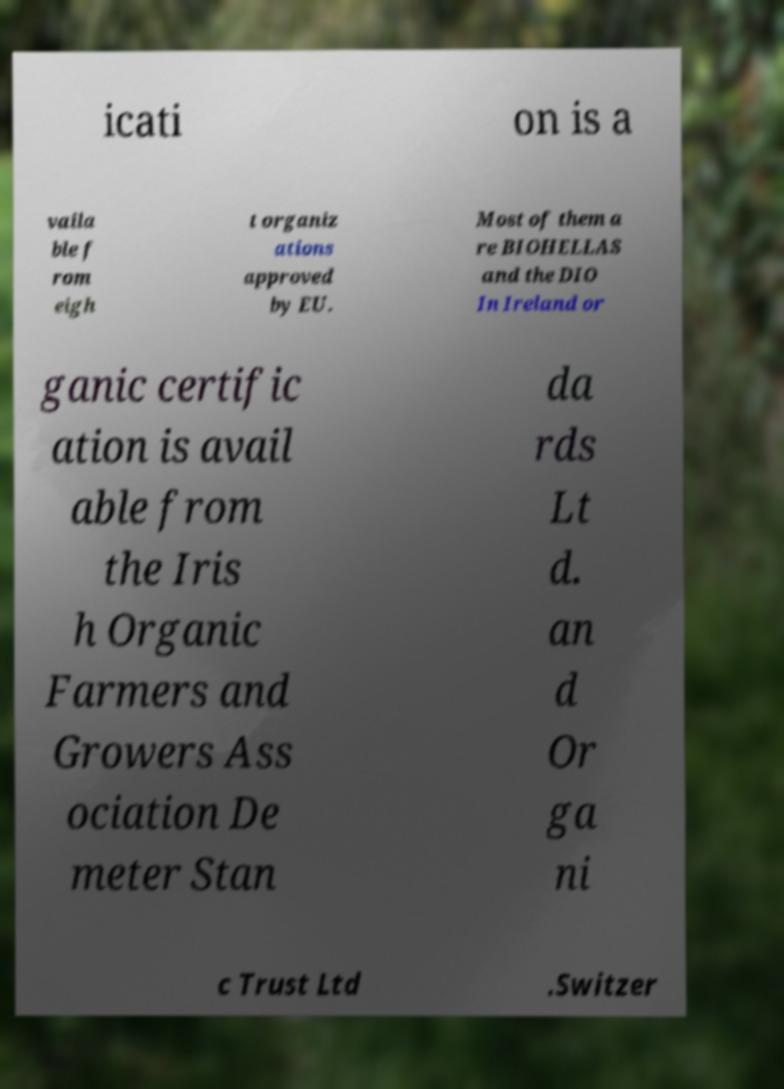There's text embedded in this image that I need extracted. Can you transcribe it verbatim? icati on is a vaila ble f rom eigh t organiz ations approved by EU. Most of them a re BIOHELLAS and the DIO In Ireland or ganic certific ation is avail able from the Iris h Organic Farmers and Growers Ass ociation De meter Stan da rds Lt d. an d Or ga ni c Trust Ltd .Switzer 